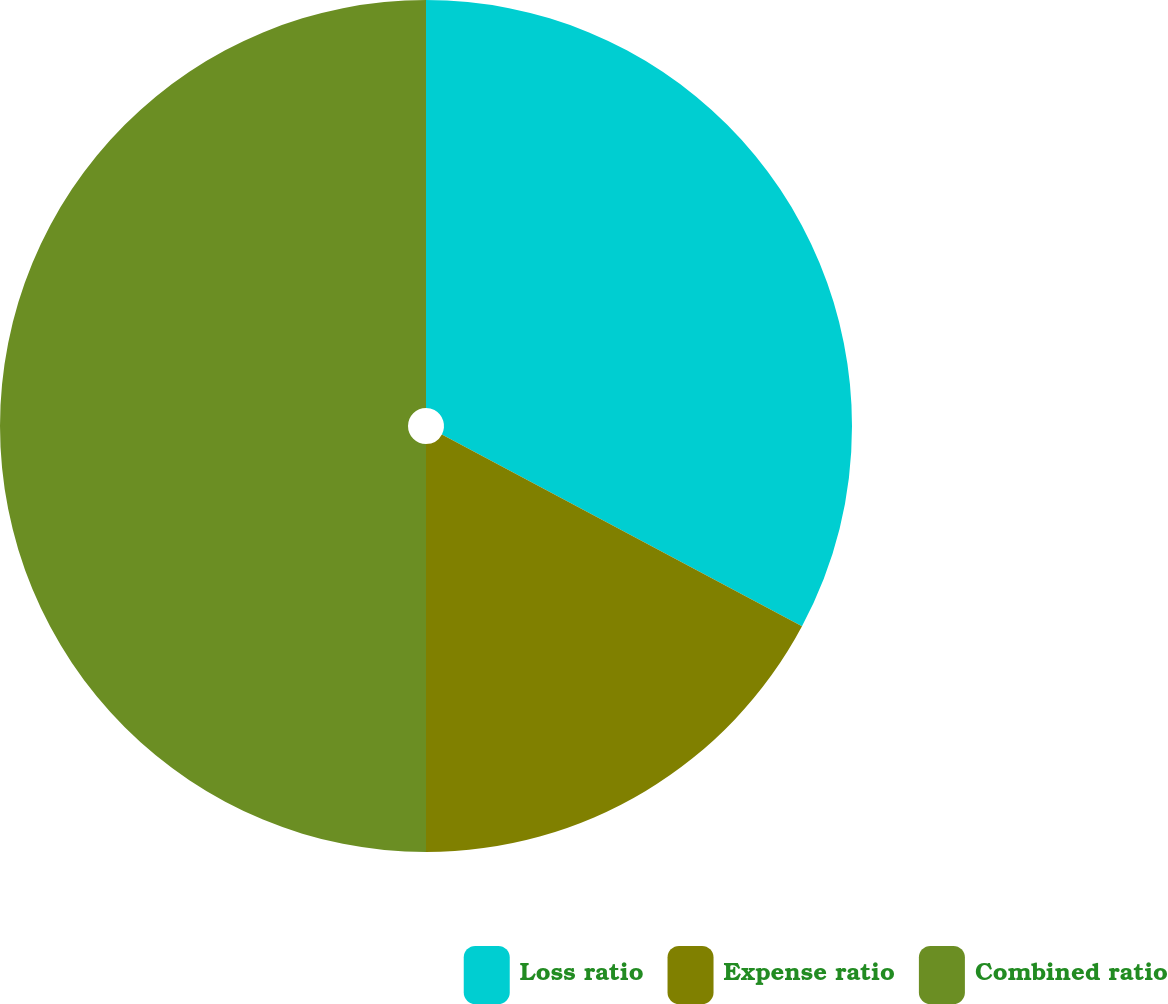Convert chart to OTSL. <chart><loc_0><loc_0><loc_500><loc_500><pie_chart><fcel>Loss ratio<fcel>Expense ratio<fcel>Combined ratio<nl><fcel>32.79%<fcel>17.21%<fcel>50.0%<nl></chart> 